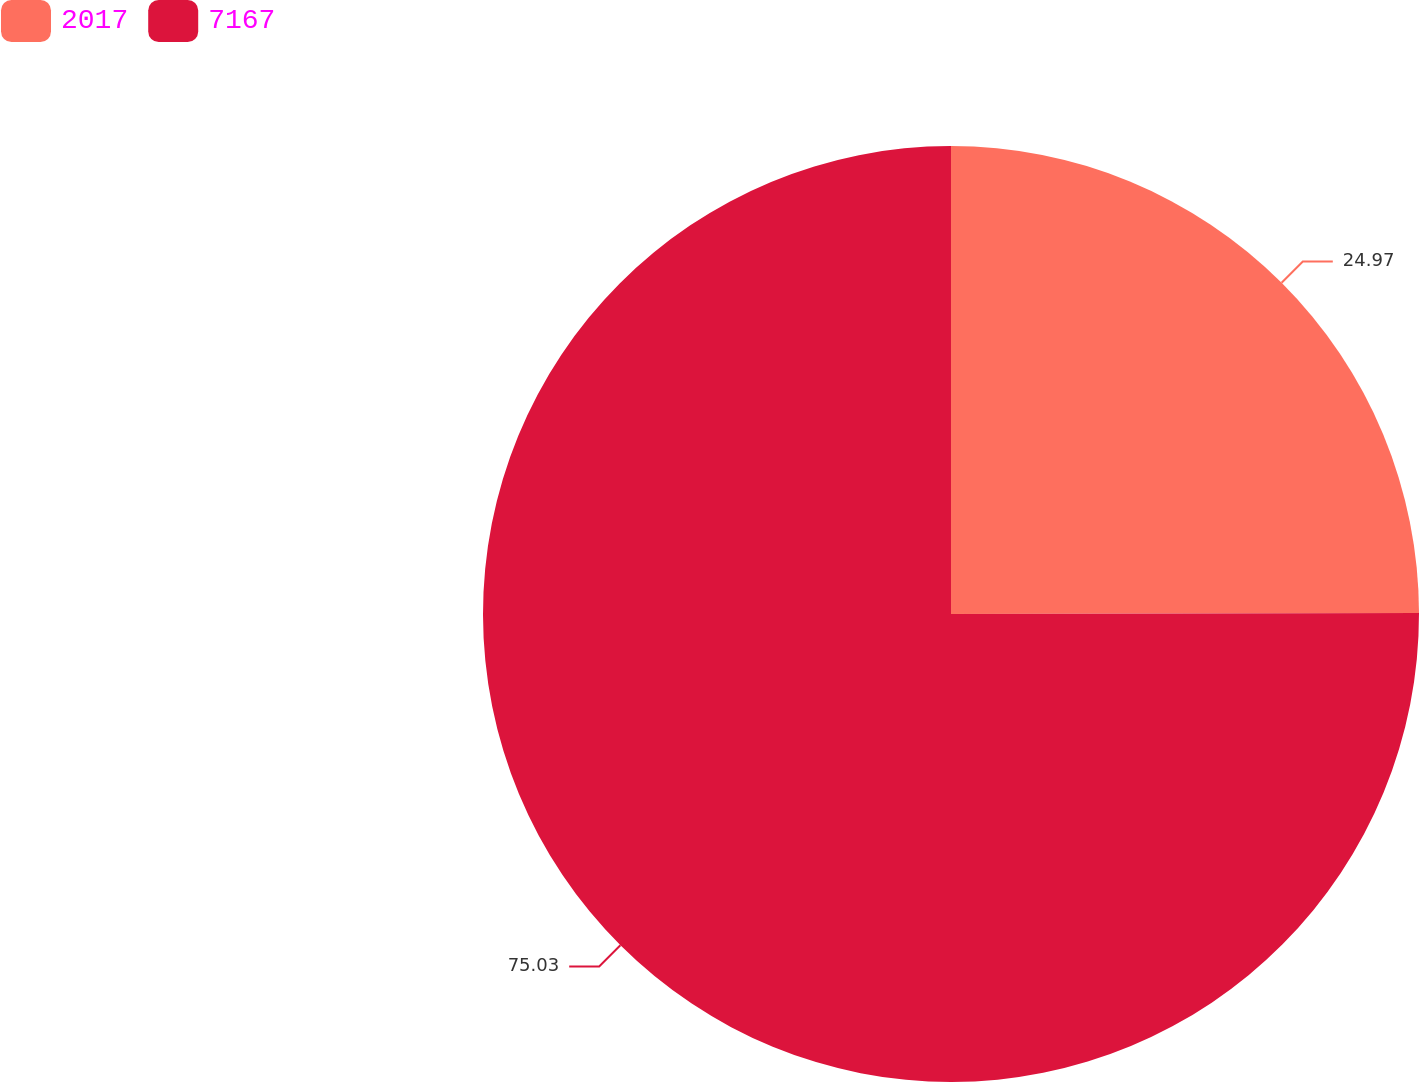Convert chart. <chart><loc_0><loc_0><loc_500><loc_500><pie_chart><fcel>2017<fcel>7167<nl><fcel>24.97%<fcel>75.03%<nl></chart> 